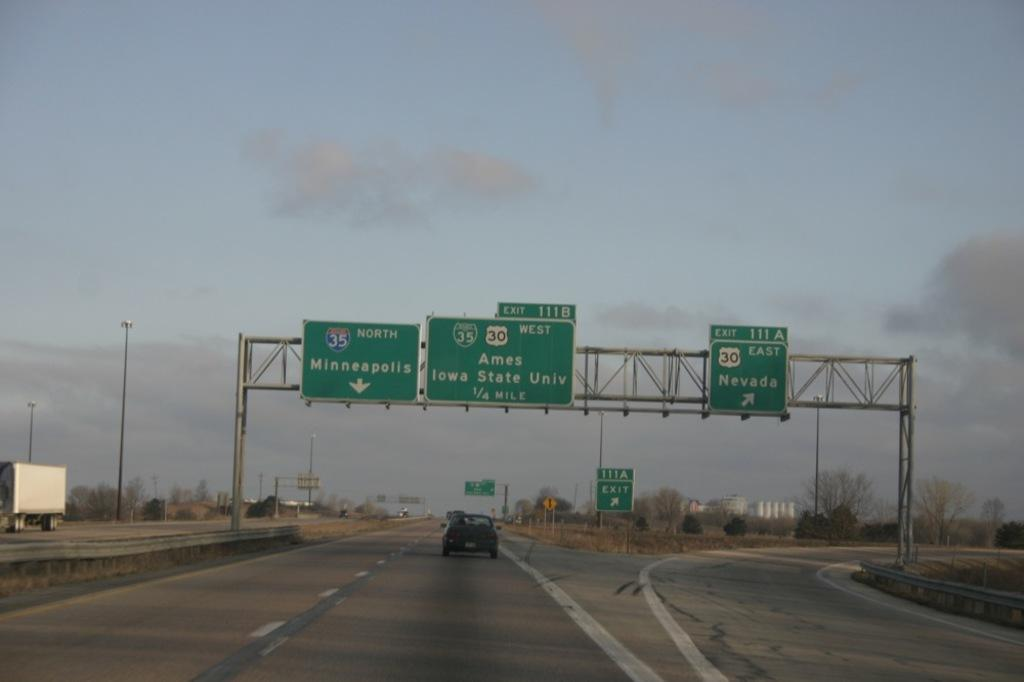<image>
Write a terse but informative summary of the picture. Exit 111 A points with an arrow towards Nevada. 